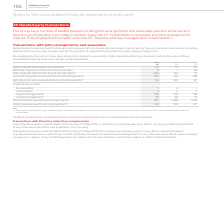From Vodafone Group Plc's financial document, Which financial years' information is shown in the table? The document contains multiple relevant values: 2017, 2018, 2019. From the document: "2019 2018 2017 €m €m €m Sales of goods and services to associates 27 19 37 Purchase of goods and services from ass 2019 2018 2017 €m €m €m Sales of go..." Also, How much is the 2019 sales of goods and services to associates? According to the financial document, 27 (in millions). The relevant text states: "m €m €m Sales of goods and services to associates 27 19 37 Purchase of goods and services from associates 3 1 90 Sales of goods and services to joint ar..." Also, How much is the 2018 sales of goods and services to associates? According to the financial document, 19 (in millions). The relevant text states: "m €m Sales of goods and services to associates 27 19 37 Purchase of goods and services from associates 3 1 90 Sales of goods and services to joint arran..." Also, can you calculate: What is the 2019 average sales of goods and services to associates ? To answer this question, I need to perform calculations using the financial data. The calculation is: (27+19)/2, which equals 23 (in millions). This is based on the information: "m €m €m Sales of goods and services to associates 27 19 37 Purchase of goods and services from associates 3 1 90 Sales of goods and services to joint ar m €m Sales of goods and services to associates ..." The key data points involved are: 19, 27. Also, can you calculate: What is the 2018 average sales of goods and services to associates? To answer this question, I need to perform calculations using the financial data. The calculation is: (19+37)/2, which equals 28 (in millions). This is based on the information: "m Sales of goods and services to associates 27 19 37 Purchase of goods and services from associates 3 1 90 Sales of goods and services to joint arrangem m €m Sales of goods and services to associates ..." The key data points involved are: 19, 37. Also, can you calculate: What is the difference between 2018 and 2019 average sales of goods and services to associates? To answer this question, I need to perform calculations using the financial data. The calculation is: [(27+19)/2] - [(19+37)/2] , which equals -5 (in millions). This is based on the information: "m €m €m Sales of goods and services to associates 27 19 37 Purchase of goods and services from associates 3 1 90 Sales of goods and services to joint ar m €m Sales of goods and services to associates ..." The key data points involved are: 19, 2, 27. 